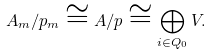<formula> <loc_0><loc_0><loc_500><loc_500>A _ { m } / p _ { m } \cong A / p \cong \bigoplus _ { i \in Q _ { 0 } } V .</formula> 